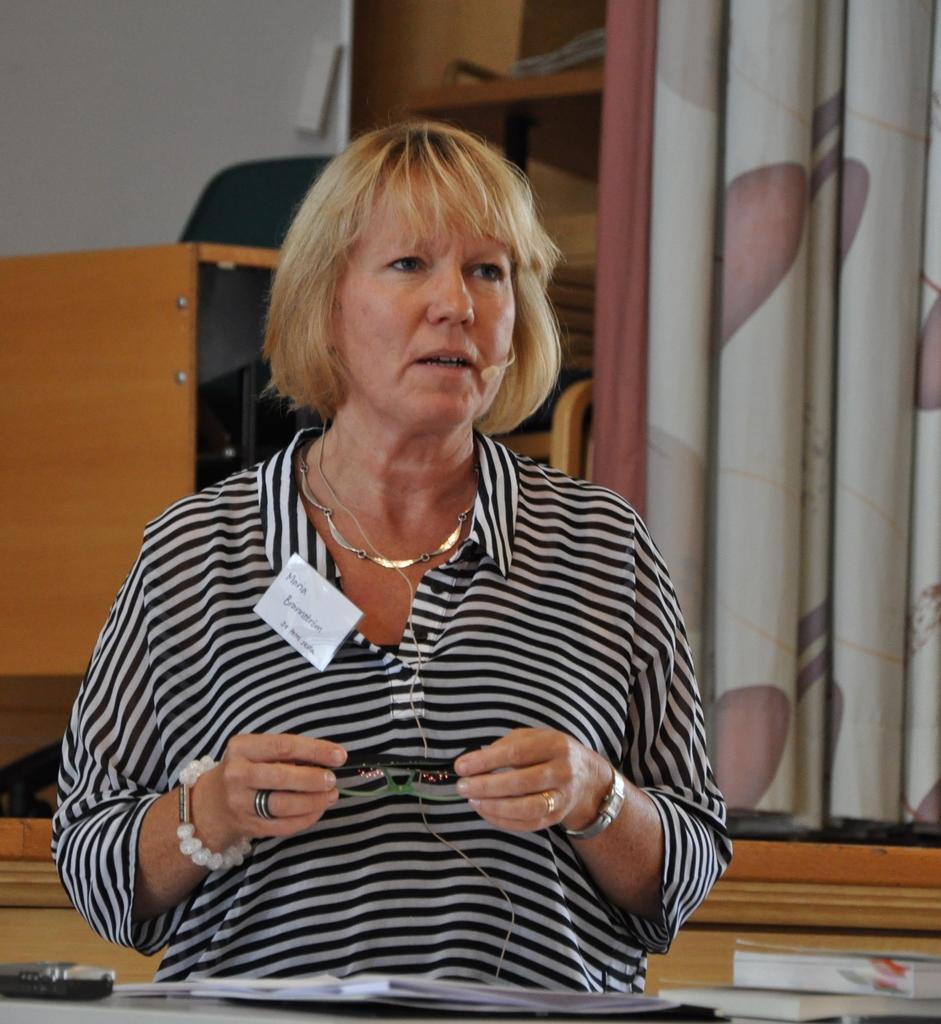How would you summarize this image in a sentence or two? At the bottom of the image there is a table, on the table there are some books and papers. In the middle of the image a woman is standing and holding glasses. Behind her there is a table and chair and curtain. Behind them there is wall. 